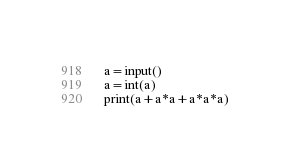<code> <loc_0><loc_0><loc_500><loc_500><_Python_>a=input()
a=int(a)
print(a+a*a+a*a*a)</code> 